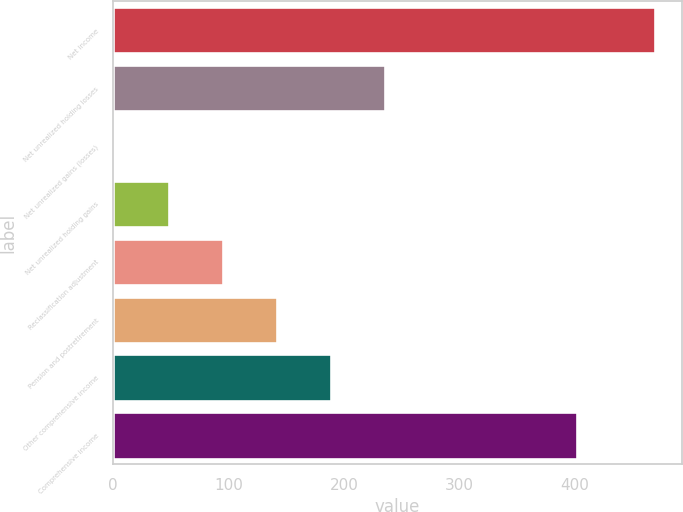<chart> <loc_0><loc_0><loc_500><loc_500><bar_chart><fcel>Net income<fcel>Net unrealized holding losses<fcel>Net unrealized gains (losses)<fcel>Net unrealized holding gains<fcel>Reclassification adjustment<fcel>Pension and postretirement<fcel>Other comprehensive income<fcel>Comprehensive income<nl><fcel>469<fcel>235.5<fcel>2<fcel>48.7<fcel>95.4<fcel>142.1<fcel>188.8<fcel>402<nl></chart> 